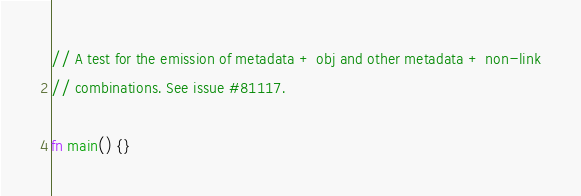<code> <loc_0><loc_0><loc_500><loc_500><_Rust_>
// A test for the emission of metadata + obj and other metadata + non-link
// combinations. See issue #81117.

fn main() {}
</code> 